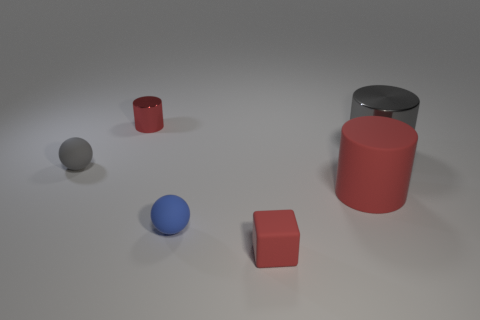Does the small red object behind the tiny rubber cube have the same material as the small blue thing?
Provide a short and direct response. No. Are there an equal number of big metallic cylinders in front of the tiny cube and big gray cylinders behind the tiny metal cylinder?
Provide a succinct answer. Yes. There is a red object in front of the big red cylinder; what is its size?
Give a very brief answer. Small. Are there any small red things made of the same material as the small blue thing?
Make the answer very short. Yes. There is a small object that is to the left of the small red shiny thing; does it have the same color as the block?
Your answer should be very brief. No. Is the number of rubber spheres to the right of the large red object the same as the number of tiny brown rubber cubes?
Your answer should be very brief. Yes. Are there any tiny metal things of the same color as the matte cube?
Your answer should be compact. Yes. Does the blue object have the same size as the red matte block?
Provide a succinct answer. Yes. There is a object that is to the left of the red cylinder behind the gray rubber thing; what size is it?
Provide a short and direct response. Small. What size is the cylinder that is both behind the small gray sphere and right of the red block?
Offer a very short reply. Large. 